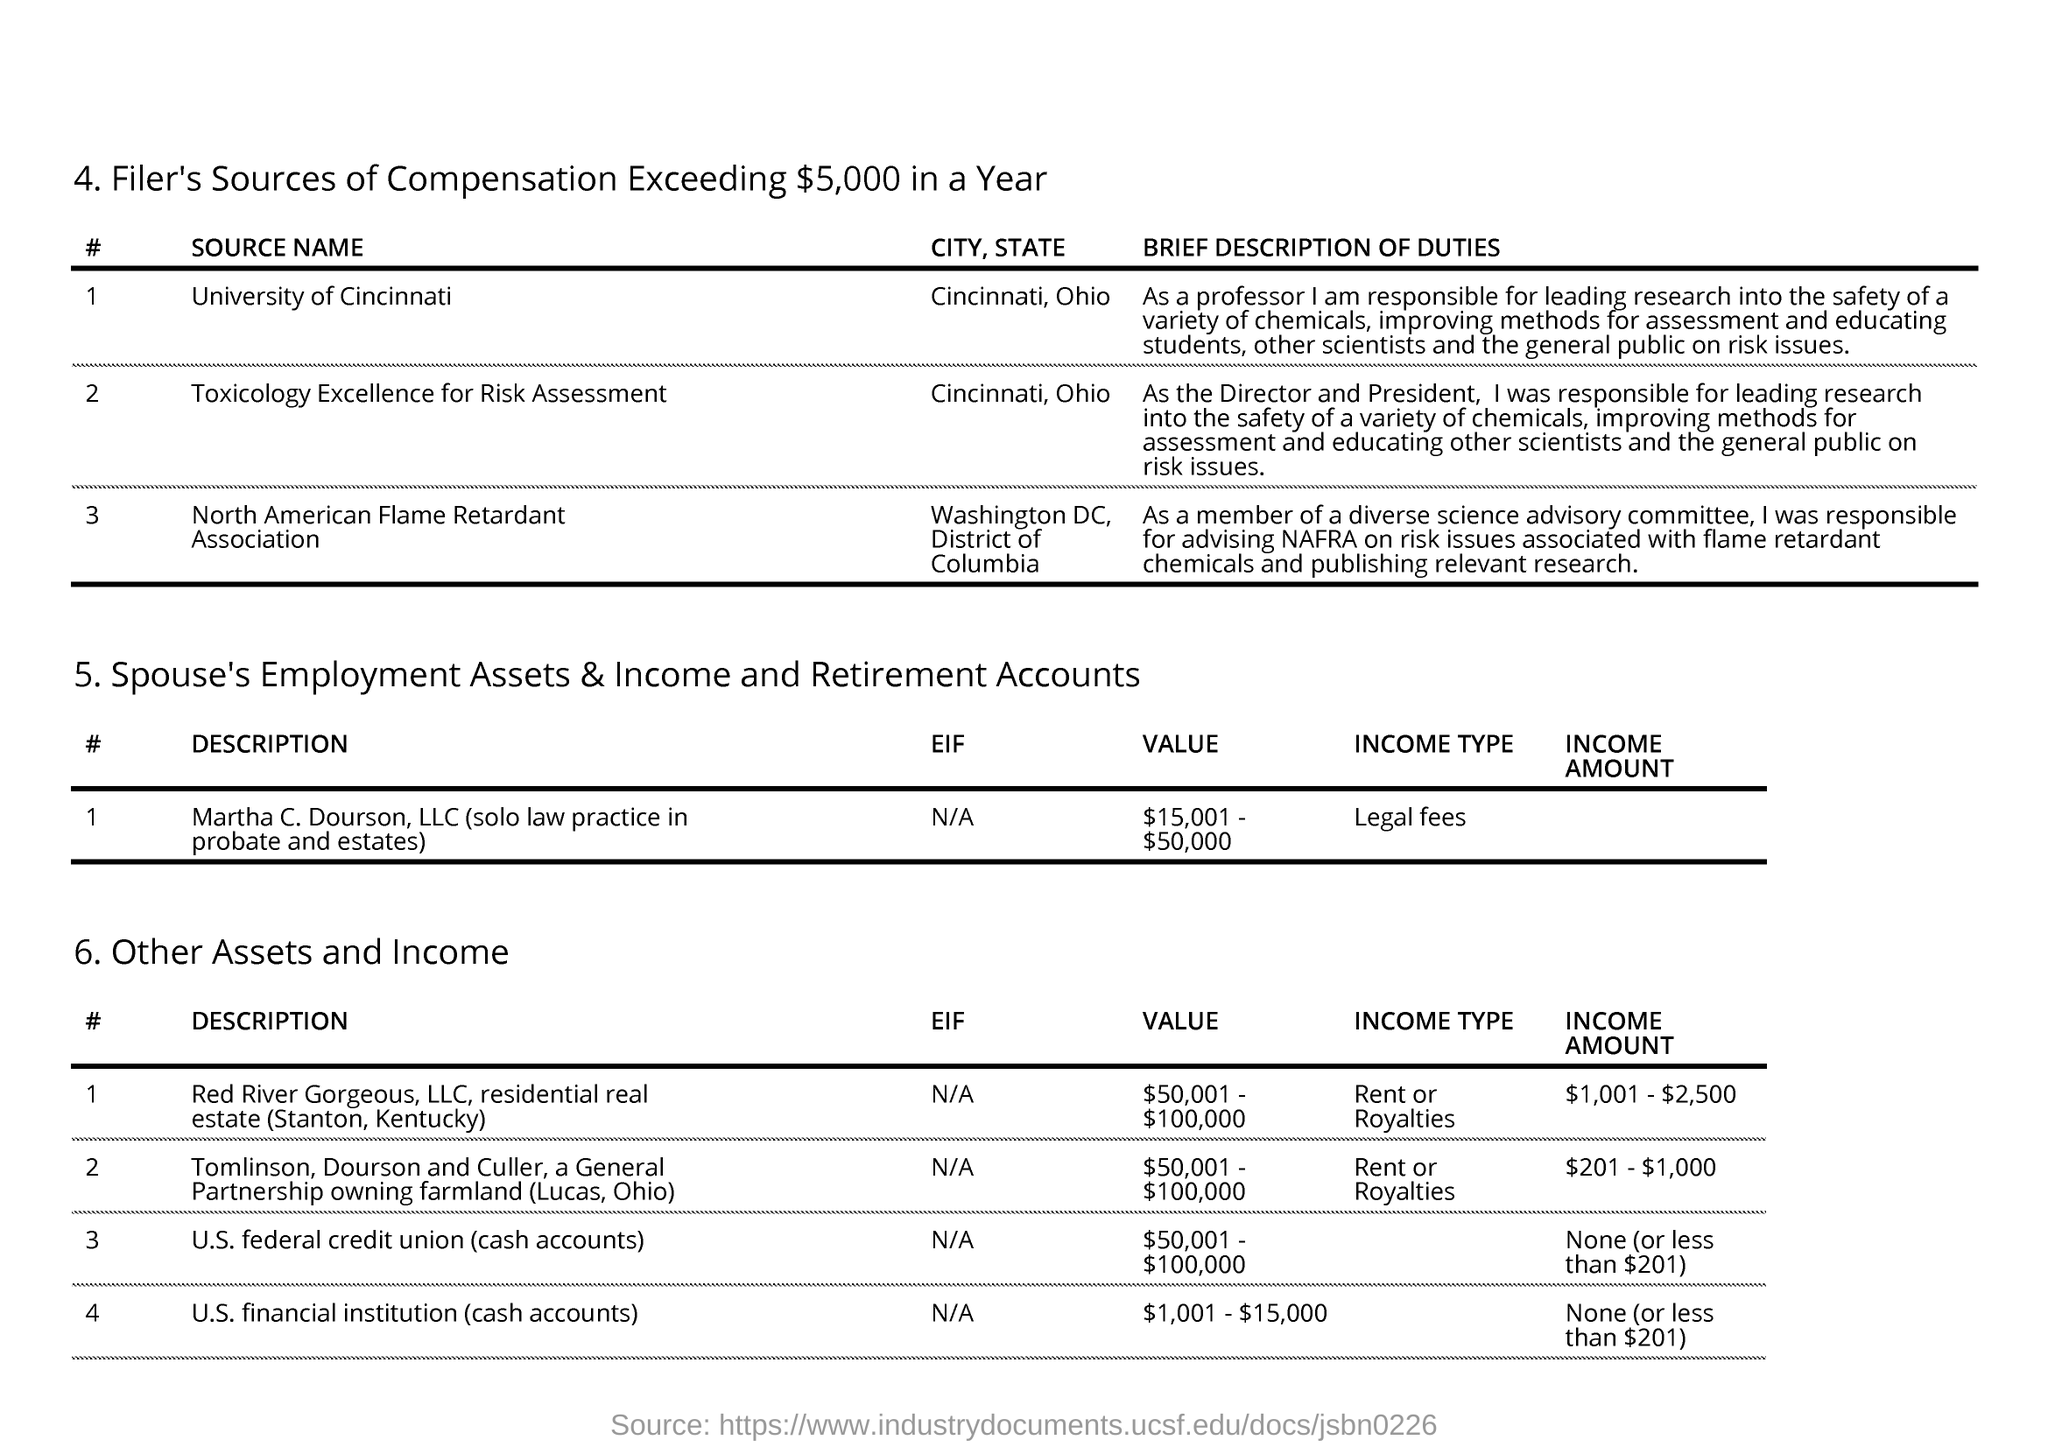What is the income type of Martha C. Dourson, LLC?
Keep it short and to the point. LEGAL FEES. What is the income type of Red River Gorgeous, LLC. ?
Offer a terse response. Rent or Royalties. What is the value listed for Tomlinson, Dourson and Culler?
Make the answer very short. $50,001-$100,000. Who was responsible for educating other scientists on risk issues?
Your answer should be compact. Director and President. 